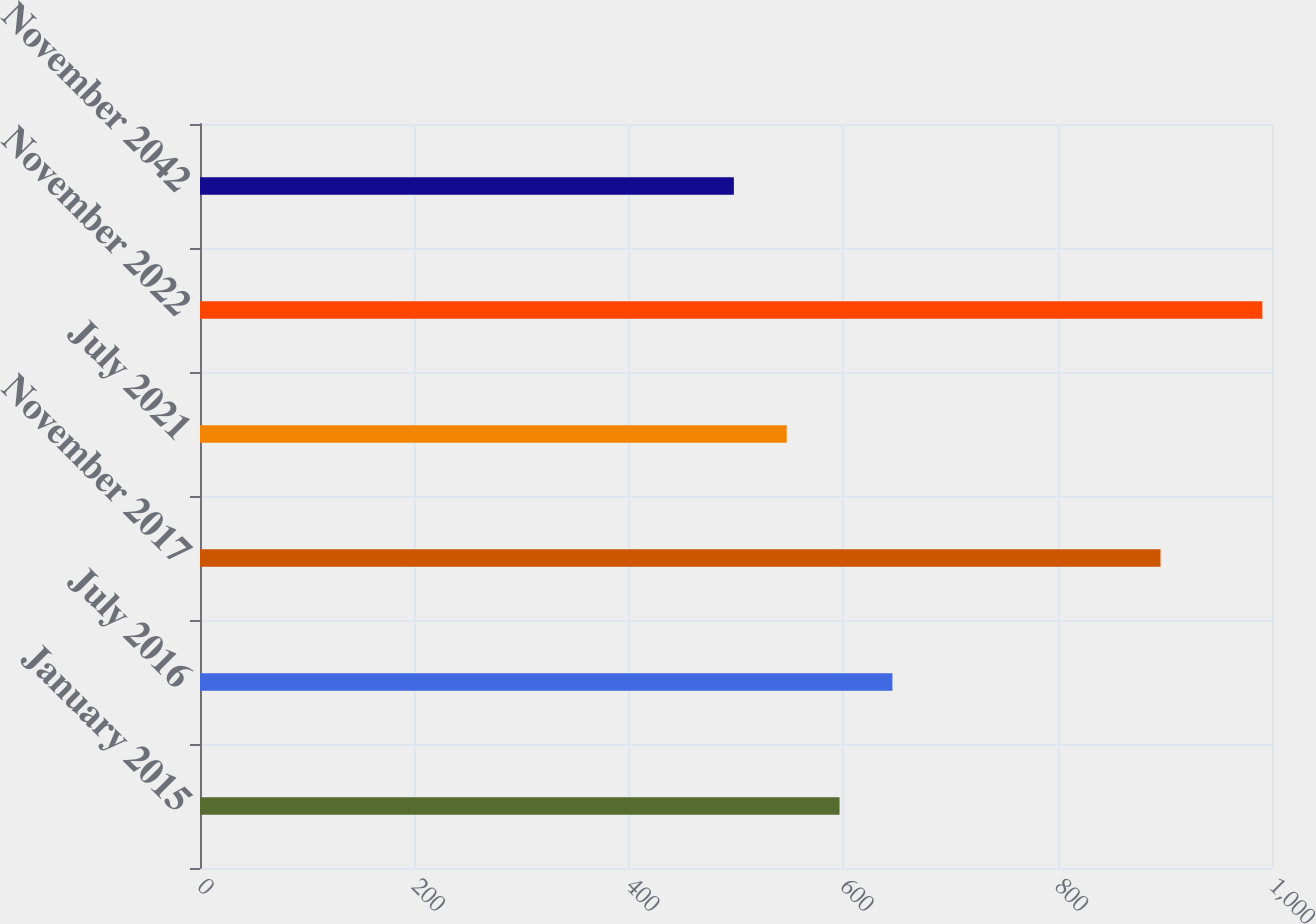Convert chart. <chart><loc_0><loc_0><loc_500><loc_500><bar_chart><fcel>January 2015<fcel>July 2016<fcel>November 2017<fcel>July 2021<fcel>November 2022<fcel>November 2042<nl><fcel>596.6<fcel>645.9<fcel>896<fcel>547.3<fcel>991<fcel>498<nl></chart> 